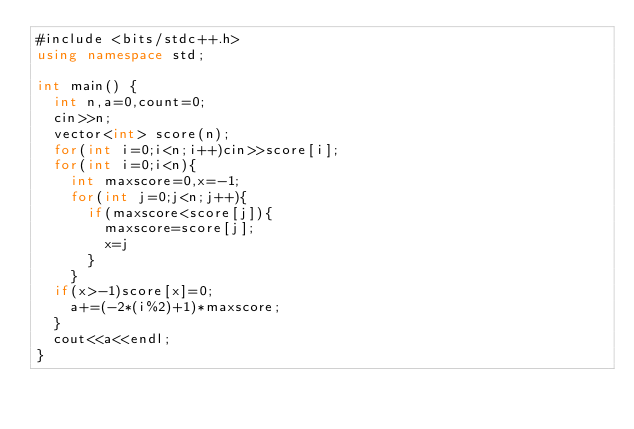<code> <loc_0><loc_0><loc_500><loc_500><_C#_>#include <bits/stdc++.h>
using namespace std;

int main() {
  int n,a=0,count=0;
  cin>>n;
  vector<int> score(n);
  for(int i=0;i<n;i++)cin>>score[i];
  for(int i=0;i<n){
    int maxscore=0,x=-1;
    for(int j=0;j<n;j++){
      if(maxscore<score[j]){
        maxscore=score[j];
        x=j
      }
    }
  if(x>-1)score[x]=0;
    a+=(-2*(i%2)+1)*maxscore;
  }
  cout<<a<<endl;
}</code> 